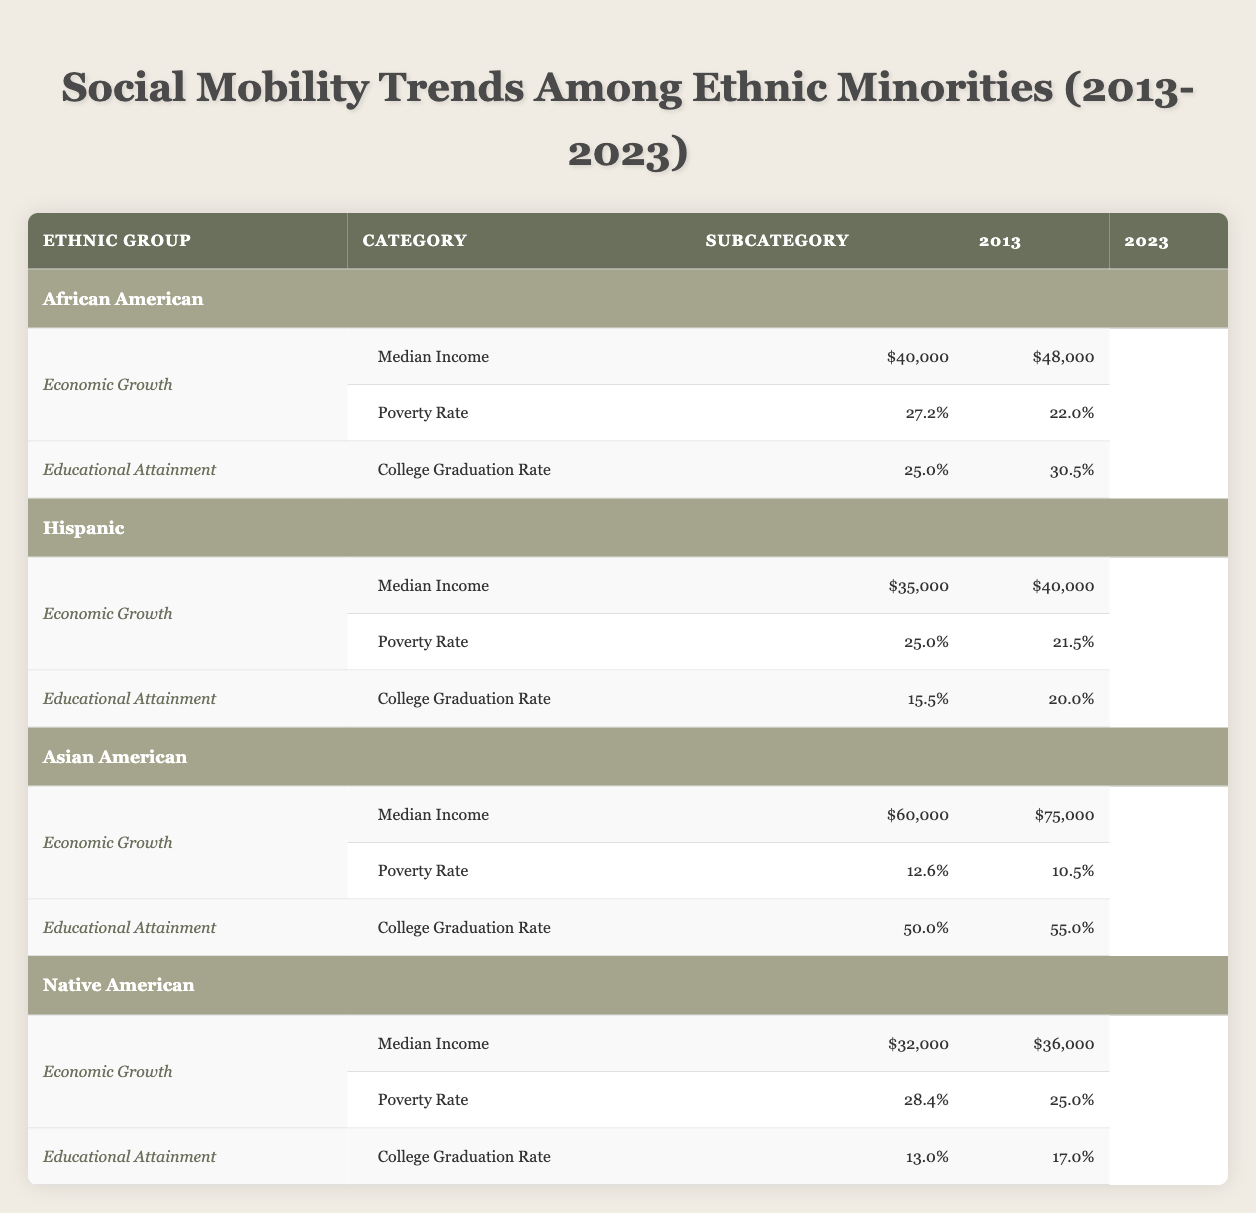What was the median income for Hispanic individuals in 2023? According to the table, the median income for Hispanic individuals in 2023 is listed as $40,000.
Answer: $40,000 What was the poverty rate for Asian Americans in 2013? The table shows that the poverty rate for Asian Americans in 2013 was 12.6%.
Answer: 12.6% How much did the median income for African Americans increase from 2013 to 2023? To find the increase, subtract the median income in 2013 ($40,000) from the median income in 2023 ($48,000). Therefore, $48,000 - $40,000 = $8,000.
Answer: $8,000 Is the college graduation rate for Native Americans in 2023 higher than that for Hispanics in the same year? The table indicates that the college graduation rate for Native Americans in 2023 is 17.0%, while for Hispanics, it is 20.0%. Since 17.0% is less than 20.0%, the statement is false.
Answer: No What is the average poverty rate across all ethnic groups in 2023? To average the poverty rates, add each group's poverty rate in 2023 (African American 22.0%, Hispanic 21.5%, Asian American 10.5%, Native American 25.0%) which totals 79.0%, then divide by the number of groups (4). The average is 79.0% / 4 = 19.75%.
Answer: 19.75% How did the college graduation rate for Asian Americans change from 2013 to 2023? The college graduation rate for Asian Americans increased from 50.0% in 2013 to 55.0% in 2023. The difference is 55.0% - 50.0% = 5.0%.
Answer: Increased by 5.0% What was the highest median income among ethnic groups in 2023? According to the table, the median income for Asian Americans in 2023 is the highest at $75,000, compared to $48,000 for African Americans, $40,000 for Hispanics, and $36,000 for Native Americans.
Answer: $75,000 Did the poverty rate for Native Americans decrease from 2013 to 2023? The poverty rate for Native Americans was 28.4% in 2013 and decreased to 25.0% in 2023. Therefore, the poverty rate did indeed decrease.
Answer: Yes 